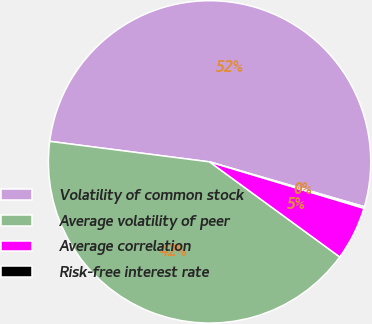Convert chart to OTSL. <chart><loc_0><loc_0><loc_500><loc_500><pie_chart><fcel>Volatility of common stock<fcel>Average volatility of peer<fcel>Average correlation<fcel>Risk-free interest rate<nl><fcel>52.46%<fcel>42.0%<fcel>5.39%<fcel>0.16%<nl></chart> 